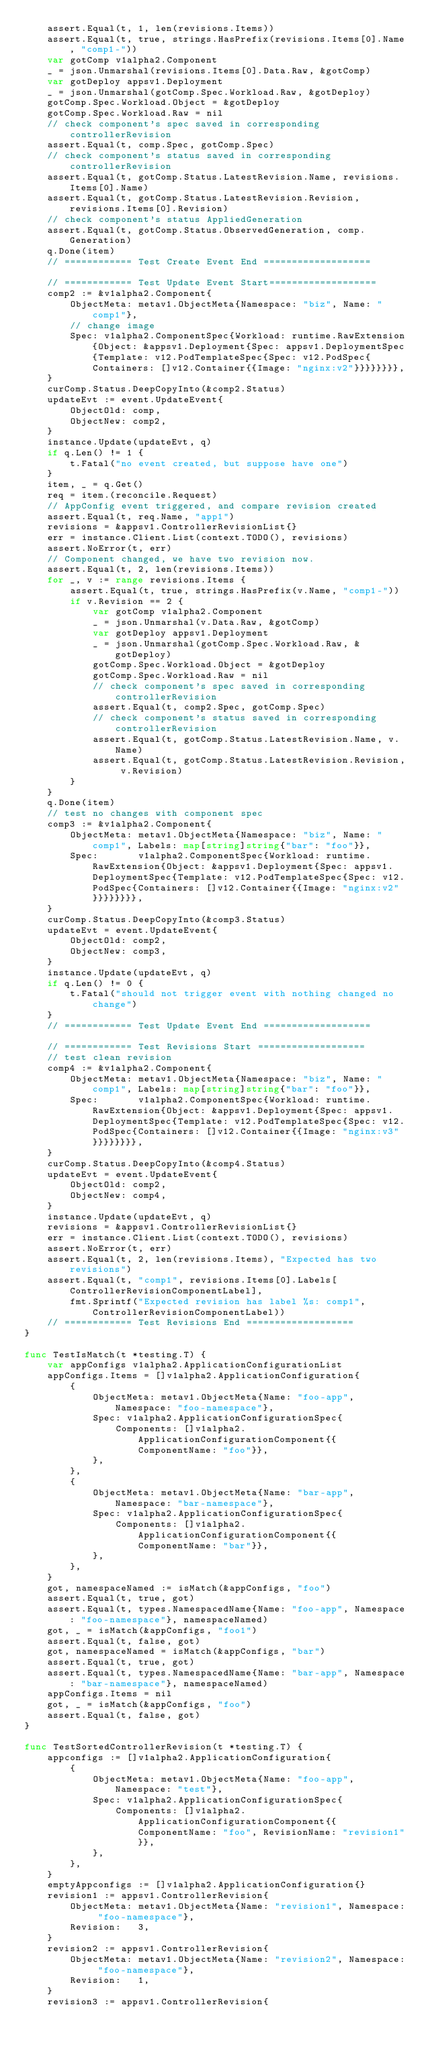<code> <loc_0><loc_0><loc_500><loc_500><_Go_>	assert.Equal(t, 1, len(revisions.Items))
	assert.Equal(t, true, strings.HasPrefix(revisions.Items[0].Name, "comp1-"))
	var gotComp v1alpha2.Component
	_ = json.Unmarshal(revisions.Items[0].Data.Raw, &gotComp)
	var gotDeploy appsv1.Deployment
	_ = json.Unmarshal(gotComp.Spec.Workload.Raw, &gotDeploy)
	gotComp.Spec.Workload.Object = &gotDeploy
	gotComp.Spec.Workload.Raw = nil
	// check component's spec saved in corresponding controllerRevision
	assert.Equal(t, comp.Spec, gotComp.Spec)
	// check component's status saved in corresponding controllerRevision
	assert.Equal(t, gotComp.Status.LatestRevision.Name, revisions.Items[0].Name)
	assert.Equal(t, gotComp.Status.LatestRevision.Revision, revisions.Items[0].Revision)
	// check component's status AppliedGeneration
	assert.Equal(t, gotComp.Status.ObservedGeneration, comp.Generation)
	q.Done(item)
	// ============ Test Create Event End ===================

	// ============ Test Update Event Start===================
	comp2 := &v1alpha2.Component{
		ObjectMeta: metav1.ObjectMeta{Namespace: "biz", Name: "comp1"},
		// change image
		Spec: v1alpha2.ComponentSpec{Workload: runtime.RawExtension{Object: &appsv1.Deployment{Spec: appsv1.DeploymentSpec{Template: v12.PodTemplateSpec{Spec: v12.PodSpec{Containers: []v12.Container{{Image: "nginx:v2"}}}}}}}},
	}
	curComp.Status.DeepCopyInto(&comp2.Status)
	updateEvt := event.UpdateEvent{
		ObjectOld: comp,
		ObjectNew: comp2,
	}
	instance.Update(updateEvt, q)
	if q.Len() != 1 {
		t.Fatal("no event created, but suppose have one")
	}
	item, _ = q.Get()
	req = item.(reconcile.Request)
	// AppConfig event triggered, and compare revision created
	assert.Equal(t, req.Name, "app1")
	revisions = &appsv1.ControllerRevisionList{}
	err = instance.Client.List(context.TODO(), revisions)
	assert.NoError(t, err)
	// Component changed, we have two revision now.
	assert.Equal(t, 2, len(revisions.Items))
	for _, v := range revisions.Items {
		assert.Equal(t, true, strings.HasPrefix(v.Name, "comp1-"))
		if v.Revision == 2 {
			var gotComp v1alpha2.Component
			_ = json.Unmarshal(v.Data.Raw, &gotComp)
			var gotDeploy appsv1.Deployment
			_ = json.Unmarshal(gotComp.Spec.Workload.Raw, &gotDeploy)
			gotComp.Spec.Workload.Object = &gotDeploy
			gotComp.Spec.Workload.Raw = nil
			// check component's spec saved in corresponding controllerRevision
			assert.Equal(t, comp2.Spec, gotComp.Spec)
			// check component's status saved in corresponding controllerRevision
			assert.Equal(t, gotComp.Status.LatestRevision.Name, v.Name)
			assert.Equal(t, gotComp.Status.LatestRevision.Revision, v.Revision)
		}
	}
	q.Done(item)
	// test no changes with component spec
	comp3 := &v1alpha2.Component{
		ObjectMeta: metav1.ObjectMeta{Namespace: "biz", Name: "comp1", Labels: map[string]string{"bar": "foo"}},
		Spec:       v1alpha2.ComponentSpec{Workload: runtime.RawExtension{Object: &appsv1.Deployment{Spec: appsv1.DeploymentSpec{Template: v12.PodTemplateSpec{Spec: v12.PodSpec{Containers: []v12.Container{{Image: "nginx:v2"}}}}}}}},
	}
	curComp.Status.DeepCopyInto(&comp3.Status)
	updateEvt = event.UpdateEvent{
		ObjectOld: comp2,
		ObjectNew: comp3,
	}
	instance.Update(updateEvt, q)
	if q.Len() != 0 {
		t.Fatal("should not trigger event with nothing changed no change")
	}
	// ============ Test Update Event End ===================

	// ============ Test Revisions Start ===================
	// test clean revision
	comp4 := &v1alpha2.Component{
		ObjectMeta: metav1.ObjectMeta{Namespace: "biz", Name: "comp1", Labels: map[string]string{"bar": "foo"}},
		Spec:       v1alpha2.ComponentSpec{Workload: runtime.RawExtension{Object: &appsv1.Deployment{Spec: appsv1.DeploymentSpec{Template: v12.PodTemplateSpec{Spec: v12.PodSpec{Containers: []v12.Container{{Image: "nginx:v3"}}}}}}}},
	}
	curComp.Status.DeepCopyInto(&comp4.Status)
	updateEvt = event.UpdateEvent{
		ObjectOld: comp2,
		ObjectNew: comp4,
	}
	instance.Update(updateEvt, q)
	revisions = &appsv1.ControllerRevisionList{}
	err = instance.Client.List(context.TODO(), revisions)
	assert.NoError(t, err)
	assert.Equal(t, 2, len(revisions.Items), "Expected has two revisions")
	assert.Equal(t, "comp1", revisions.Items[0].Labels[ControllerRevisionComponentLabel],
		fmt.Sprintf("Expected revision has label %s: comp1", ControllerRevisionComponentLabel))
	// ============ Test Revisions End ===================
}

func TestIsMatch(t *testing.T) {
	var appConfigs v1alpha2.ApplicationConfigurationList
	appConfigs.Items = []v1alpha2.ApplicationConfiguration{
		{
			ObjectMeta: metav1.ObjectMeta{Name: "foo-app", Namespace: "foo-namespace"},
			Spec: v1alpha2.ApplicationConfigurationSpec{
				Components: []v1alpha2.ApplicationConfigurationComponent{{ComponentName: "foo"}},
			},
		},
		{
			ObjectMeta: metav1.ObjectMeta{Name: "bar-app", Namespace: "bar-namespace"},
			Spec: v1alpha2.ApplicationConfigurationSpec{
				Components: []v1alpha2.ApplicationConfigurationComponent{{ComponentName: "bar"}},
			},
		},
	}
	got, namespaceNamed := isMatch(&appConfigs, "foo")
	assert.Equal(t, true, got)
	assert.Equal(t, types.NamespacedName{Name: "foo-app", Namespace: "foo-namespace"}, namespaceNamed)
	got, _ = isMatch(&appConfigs, "foo1")
	assert.Equal(t, false, got)
	got, namespaceNamed = isMatch(&appConfigs, "bar")
	assert.Equal(t, true, got)
	assert.Equal(t, types.NamespacedName{Name: "bar-app", Namespace: "bar-namespace"}, namespaceNamed)
	appConfigs.Items = nil
	got, _ = isMatch(&appConfigs, "foo")
	assert.Equal(t, false, got)
}

func TestSortedControllerRevision(t *testing.T) {
	appconfigs := []v1alpha2.ApplicationConfiguration{
		{
			ObjectMeta: metav1.ObjectMeta{Name: "foo-app", Namespace: "test"},
			Spec: v1alpha2.ApplicationConfigurationSpec{
				Components: []v1alpha2.ApplicationConfigurationComponent{{ComponentName: "foo", RevisionName: "revision1"}},
			},
		},
	}
	emptyAppconfigs := []v1alpha2.ApplicationConfiguration{}
	revision1 := appsv1.ControllerRevision{
		ObjectMeta: metav1.ObjectMeta{Name: "revision1", Namespace: "foo-namespace"},
		Revision:   3,
	}
	revision2 := appsv1.ControllerRevision{
		ObjectMeta: metav1.ObjectMeta{Name: "revision2", Namespace: "foo-namespace"},
		Revision:   1,
	}
	revision3 := appsv1.ControllerRevision{</code> 